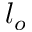Convert formula to latex. <formula><loc_0><loc_0><loc_500><loc_500>l _ { o }</formula> 